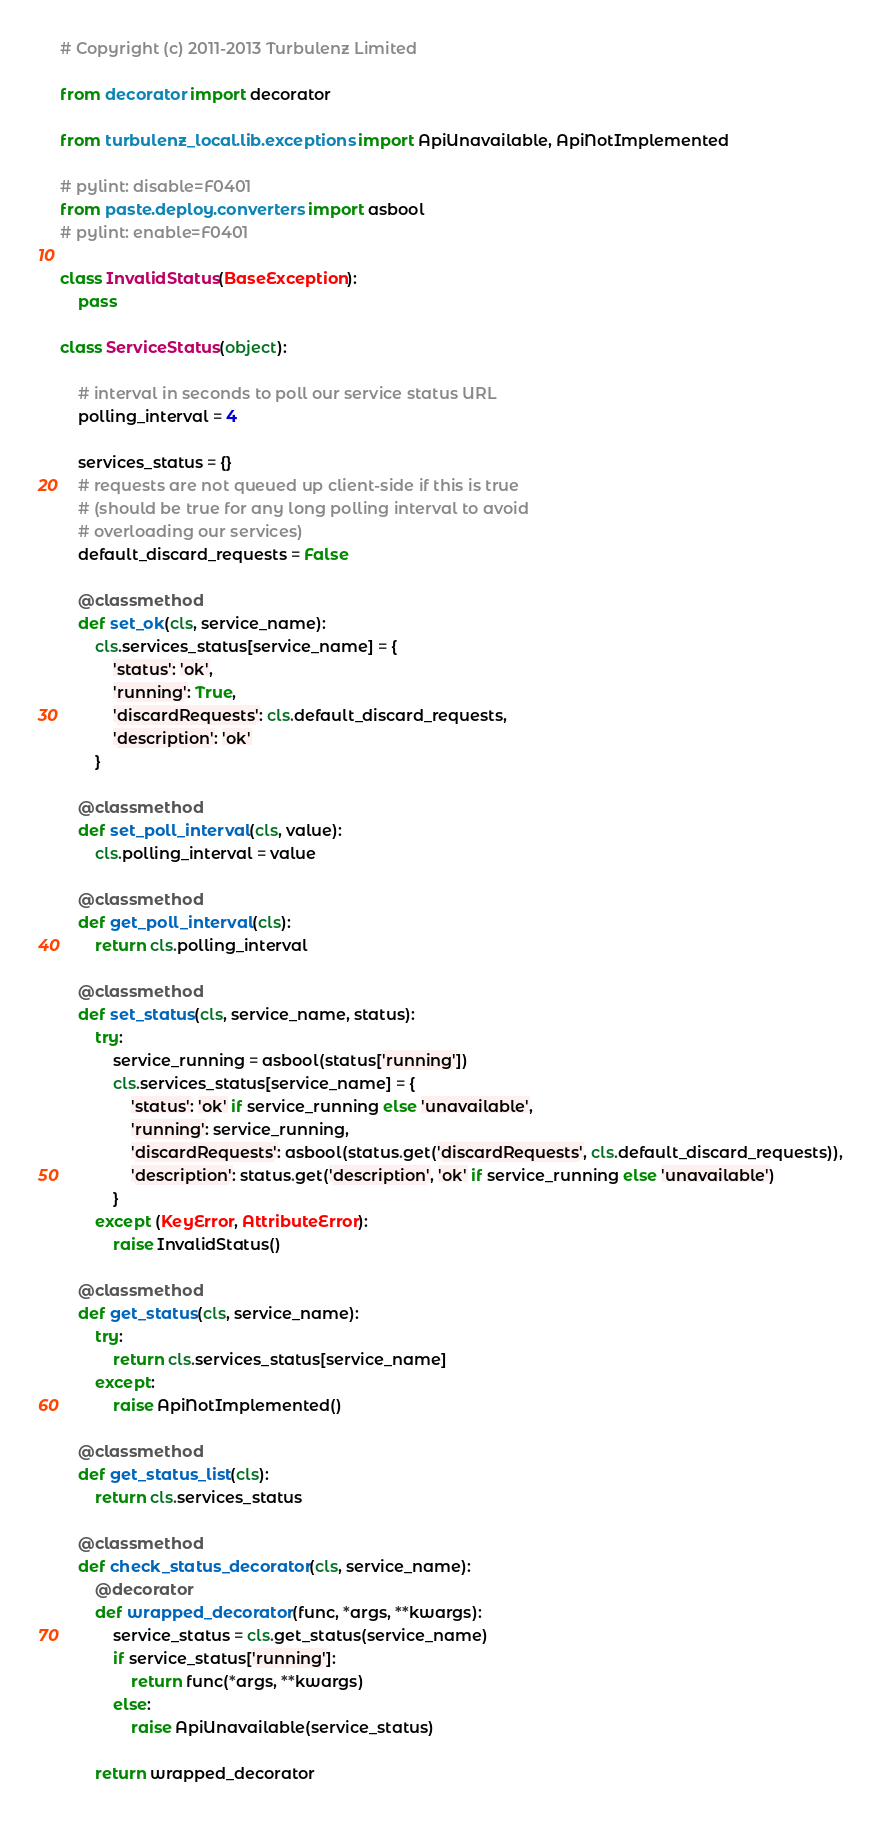<code> <loc_0><loc_0><loc_500><loc_500><_Python_># Copyright (c) 2011-2013 Turbulenz Limited

from decorator import decorator

from turbulenz_local.lib.exceptions import ApiUnavailable, ApiNotImplemented

# pylint: disable=F0401
from paste.deploy.converters import asbool
# pylint: enable=F0401

class InvalidStatus(BaseException):
    pass

class ServiceStatus(object):

    # interval in seconds to poll our service status URL
    polling_interval = 4

    services_status = {}
    # requests are not queued up client-side if this is true
    # (should be true for any long polling interval to avoid
    # overloading our services)
    default_discard_requests = False

    @classmethod
    def set_ok(cls, service_name):
        cls.services_status[service_name] = {
            'status': 'ok',
            'running': True,
            'discardRequests': cls.default_discard_requests,
            'description': 'ok'
        }

    @classmethod
    def set_poll_interval(cls, value):
        cls.polling_interval = value

    @classmethod
    def get_poll_interval(cls):
        return cls.polling_interval

    @classmethod
    def set_status(cls, service_name, status):
        try:
            service_running = asbool(status['running'])
            cls.services_status[service_name] = {
                'status': 'ok' if service_running else 'unavailable',
                'running': service_running,
                'discardRequests': asbool(status.get('discardRequests', cls.default_discard_requests)),
                'description': status.get('description', 'ok' if service_running else 'unavailable')
            }
        except (KeyError, AttributeError):
            raise InvalidStatus()

    @classmethod
    def get_status(cls, service_name):
        try:
            return cls.services_status[service_name]
        except:
            raise ApiNotImplemented()

    @classmethod
    def get_status_list(cls):
        return cls.services_status

    @classmethod
    def check_status_decorator(cls, service_name):
        @decorator
        def wrapped_decorator(func, *args, **kwargs):
            service_status = cls.get_status(service_name)
            if service_status['running']:
                return func(*args, **kwargs)
            else:
                raise ApiUnavailable(service_status)

        return wrapped_decorator
</code> 